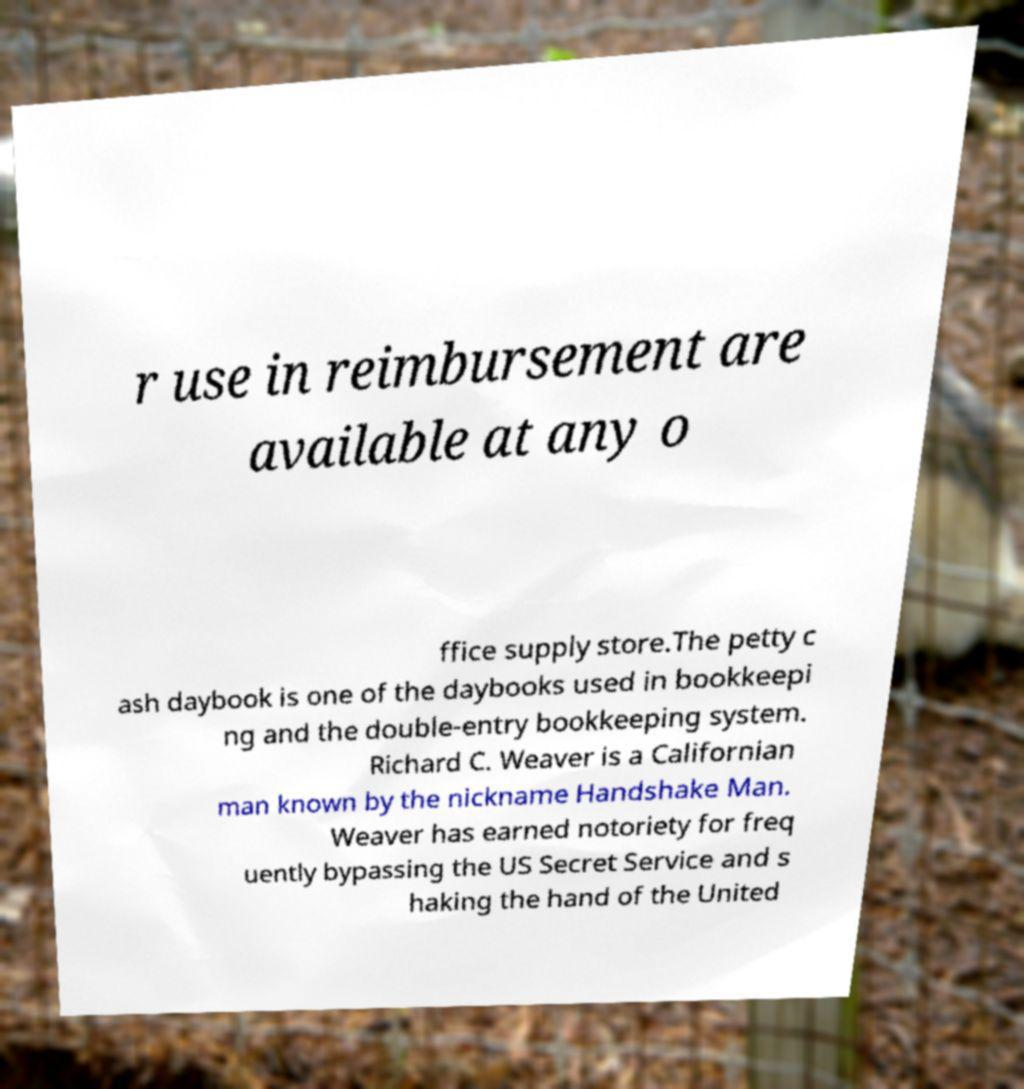Please identify and transcribe the text found in this image. r use in reimbursement are available at any o ffice supply store.The petty c ash daybook is one of the daybooks used in bookkeepi ng and the double-entry bookkeeping system. Richard C. Weaver is a Californian man known by the nickname Handshake Man. Weaver has earned notoriety for freq uently bypassing the US Secret Service and s haking the hand of the United 